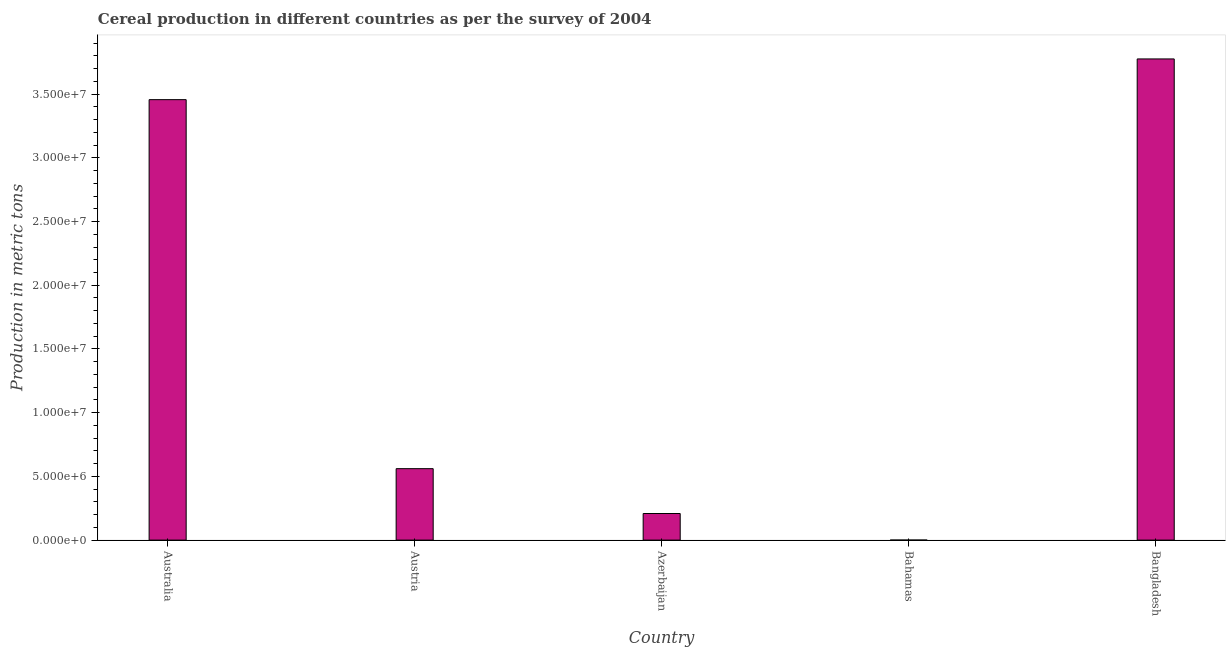What is the title of the graph?
Your answer should be compact. Cereal production in different countries as per the survey of 2004. What is the label or title of the X-axis?
Offer a very short reply. Country. What is the label or title of the Y-axis?
Provide a short and direct response. Production in metric tons. What is the cereal production in Azerbaijan?
Offer a terse response. 2.09e+06. Across all countries, what is the maximum cereal production?
Offer a terse response. 3.78e+07. Across all countries, what is the minimum cereal production?
Provide a short and direct response. 355. In which country was the cereal production minimum?
Keep it short and to the point. Bahamas. What is the sum of the cereal production?
Make the answer very short. 8.00e+07. What is the difference between the cereal production in Azerbaijan and Bahamas?
Offer a very short reply. 2.09e+06. What is the average cereal production per country?
Ensure brevity in your answer.  1.60e+07. What is the median cereal production?
Give a very brief answer. 5.61e+06. In how many countries, is the cereal production greater than 19000000 metric tons?
Give a very brief answer. 2. What is the ratio of the cereal production in Azerbaijan to that in Bangladesh?
Your response must be concise. 0.06. Is the difference between the cereal production in Australia and Bahamas greater than the difference between any two countries?
Your answer should be very brief. No. What is the difference between the highest and the second highest cereal production?
Make the answer very short. 3.20e+06. What is the difference between the highest and the lowest cereal production?
Give a very brief answer. 3.78e+07. In how many countries, is the cereal production greater than the average cereal production taken over all countries?
Ensure brevity in your answer.  2. How many bars are there?
Ensure brevity in your answer.  5. Are all the bars in the graph horizontal?
Ensure brevity in your answer.  No. How many countries are there in the graph?
Provide a succinct answer. 5. What is the Production in metric tons of Australia?
Provide a short and direct response. 3.46e+07. What is the Production in metric tons in Austria?
Provide a short and direct response. 5.61e+06. What is the Production in metric tons in Azerbaijan?
Your answer should be compact. 2.09e+06. What is the Production in metric tons of Bahamas?
Offer a terse response. 355. What is the Production in metric tons of Bangladesh?
Provide a short and direct response. 3.78e+07. What is the difference between the Production in metric tons in Australia and Austria?
Your response must be concise. 2.90e+07. What is the difference between the Production in metric tons in Australia and Azerbaijan?
Your response must be concise. 3.25e+07. What is the difference between the Production in metric tons in Australia and Bahamas?
Provide a short and direct response. 3.46e+07. What is the difference between the Production in metric tons in Australia and Bangladesh?
Keep it short and to the point. -3.20e+06. What is the difference between the Production in metric tons in Austria and Azerbaijan?
Give a very brief answer. 3.52e+06. What is the difference between the Production in metric tons in Austria and Bahamas?
Make the answer very short. 5.61e+06. What is the difference between the Production in metric tons in Austria and Bangladesh?
Your answer should be very brief. -3.22e+07. What is the difference between the Production in metric tons in Azerbaijan and Bahamas?
Provide a short and direct response. 2.09e+06. What is the difference between the Production in metric tons in Azerbaijan and Bangladesh?
Offer a very short reply. -3.57e+07. What is the difference between the Production in metric tons in Bahamas and Bangladesh?
Offer a terse response. -3.78e+07. What is the ratio of the Production in metric tons in Australia to that in Austria?
Your response must be concise. 6.17. What is the ratio of the Production in metric tons in Australia to that in Azerbaijan?
Make the answer very short. 16.56. What is the ratio of the Production in metric tons in Australia to that in Bahamas?
Ensure brevity in your answer.  9.74e+04. What is the ratio of the Production in metric tons in Australia to that in Bangladesh?
Your response must be concise. 0.92. What is the ratio of the Production in metric tons in Austria to that in Azerbaijan?
Keep it short and to the point. 2.69. What is the ratio of the Production in metric tons in Austria to that in Bahamas?
Give a very brief answer. 1.58e+04. What is the ratio of the Production in metric tons in Austria to that in Bangladesh?
Provide a short and direct response. 0.15. What is the ratio of the Production in metric tons in Azerbaijan to that in Bahamas?
Your response must be concise. 5877.86. What is the ratio of the Production in metric tons in Azerbaijan to that in Bangladesh?
Make the answer very short. 0.06. What is the ratio of the Production in metric tons in Bahamas to that in Bangladesh?
Your response must be concise. 0. 